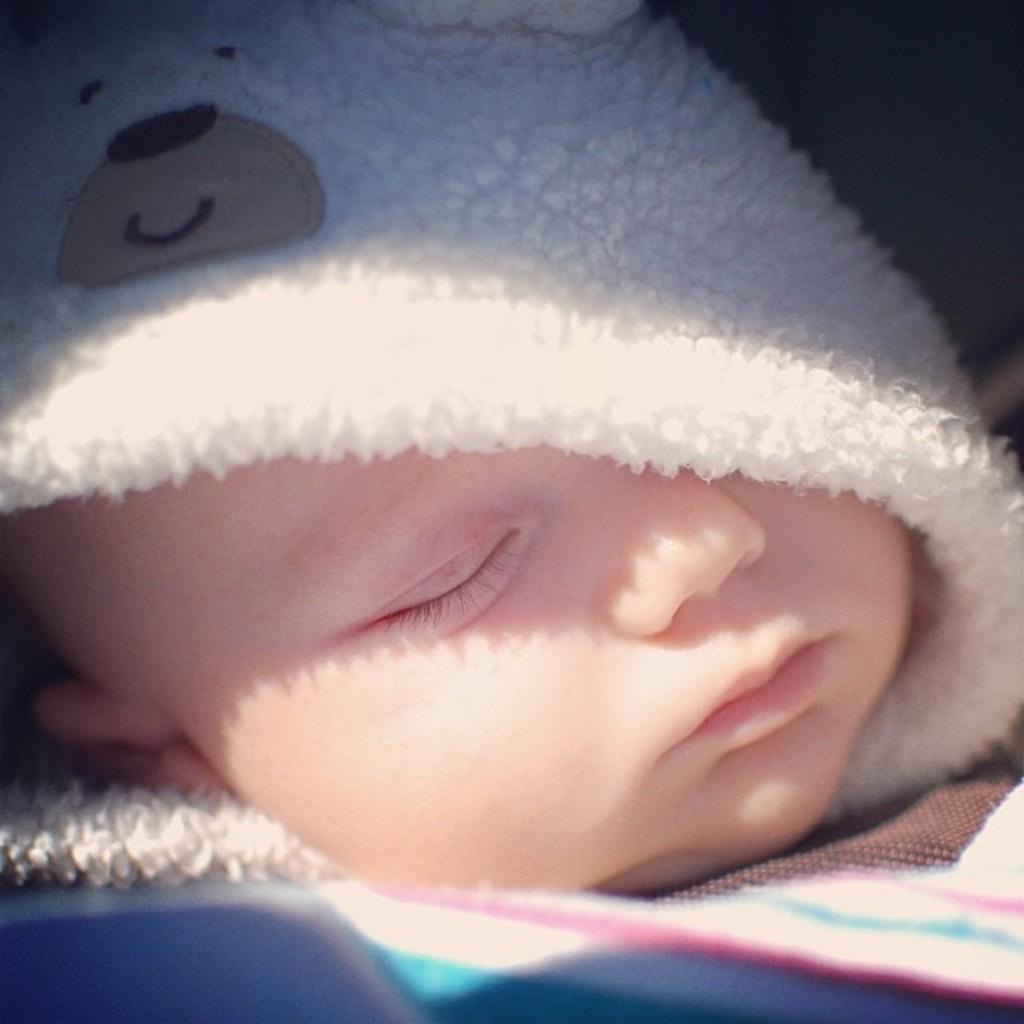What is the main subject of the image? The main subject of the image is a kid. What is the kid wearing in the image? The kid is wearing a sweater in the image. What is the kid doing in the image? The kid is sleeping in the image. What can be seen on the sweater the kid is wearing? There is a teddy bear picture on the sweater. What type of operation is being performed on the moon in the image? There is no operation being performed on the moon in the image, as the image only features a kid wearing a sweater with a teddy bear picture. 